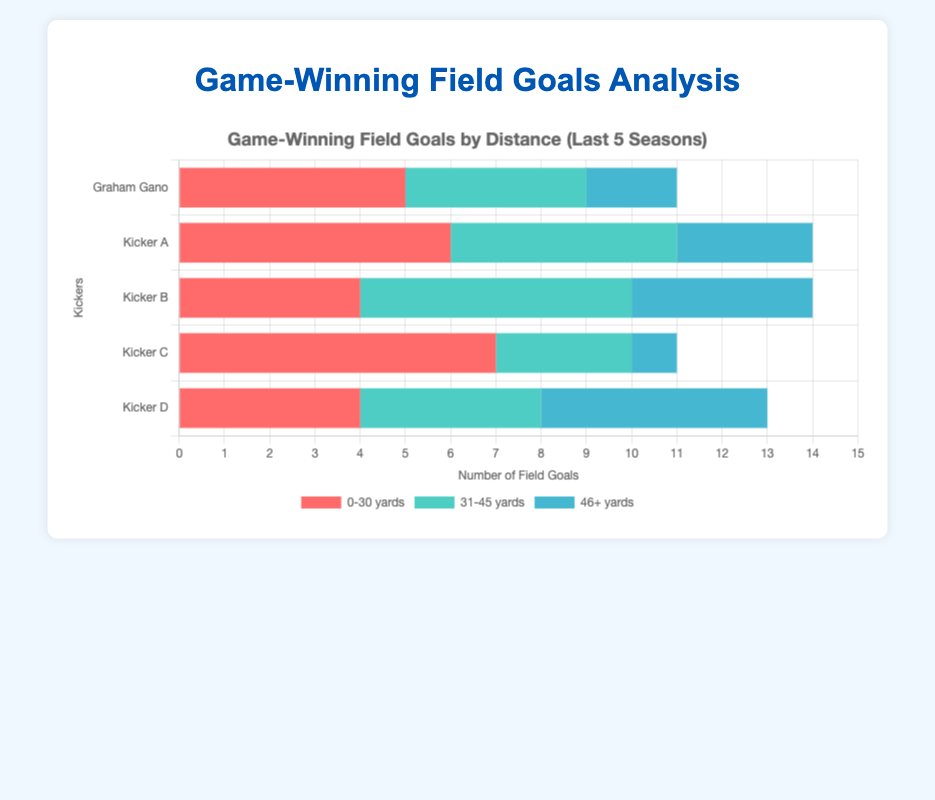How many more game-winning field goals in the 0-30 yards range did Kicker C make compared to Graham Gano? To find the difference, look at the 0-30 yards range for both kickers. Kicker C made 7, and Graham Gano made 5. So, 7 - 5 = 2.
Answer: 2 Which kicker made the most game-winning field goals in the 46+ yard range? Compare the values in the 46+ yard range. Graham Gano has 2, Kicker A has 3, Kicker B has 4, Kicker C has 1, and Kicker D has 5. Kicker D made the most with 5.
Answer: Kicker D What is the total number of game-winning field goals made by Kicker B across all distance ranges? Add the values for Kicker B across all ranges: 0-30 yards (4) + 31-45 yards (6) + 46+ yards (4). 4 + 6 + 4 = 14.
Answer: 14 In the 31-45 yard range, which kicker has the same number of game-winning field goals as Graham Gano? Look at the values in the 31-45 yard range. Graham Gano has 4. Kicker D also has 4.
Answer: Kicker D Is the number of game-winning field goals in the 0-30 yards range by Kicker A greater than the total number of field goals by Graham Gano in the 46+ yard range? Compare the values: Kicker A has 6 in the 0-30 yards range, and Graham Gano has 2 in the 46+ yard range. 6 is greater than 2.
Answer: Yes What is the average number of game-winning field goals made in the 31-45 yards range by all kickers? Add up the values in the 31-45 yards range: 4 (Gano) + 5 (A) + 6 (B) + 3 (C) + 4 (D) = 22. Then, divide by the number of kickers (5). 22 / 5 = 4.4.
Answer: 4.4 Which kicker has the highest combined total of game-winning field goals in the 0-30 yards and 31-45 yards ranges? Sum the values for each kicker in the 0-30 and 31-45 yards ranges. Graham Gano: 5+4=9, Kicker A: 6+5=11, Kicker B: 4+6=10, Kicker C: 7+3=10, Kicker D: 4+4=8. Kicker A has the highest combined total of 11.
Answer: Kicker A 